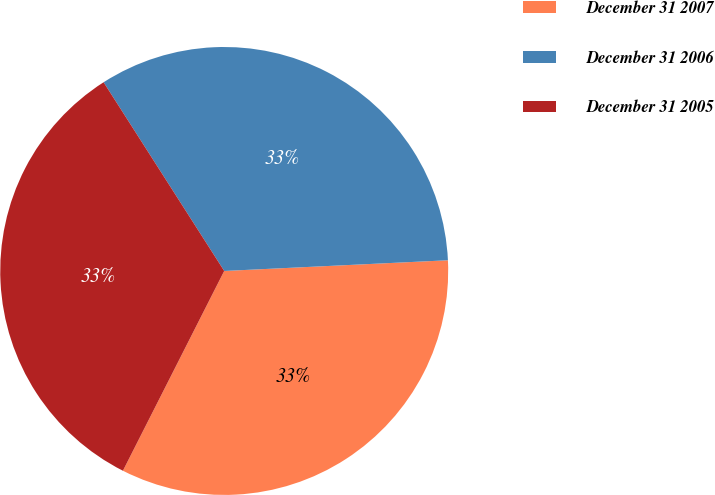Convert chart. <chart><loc_0><loc_0><loc_500><loc_500><pie_chart><fcel>December 31 2007<fcel>December 31 2006<fcel>December 31 2005<nl><fcel>33.23%<fcel>33.29%<fcel>33.48%<nl></chart> 